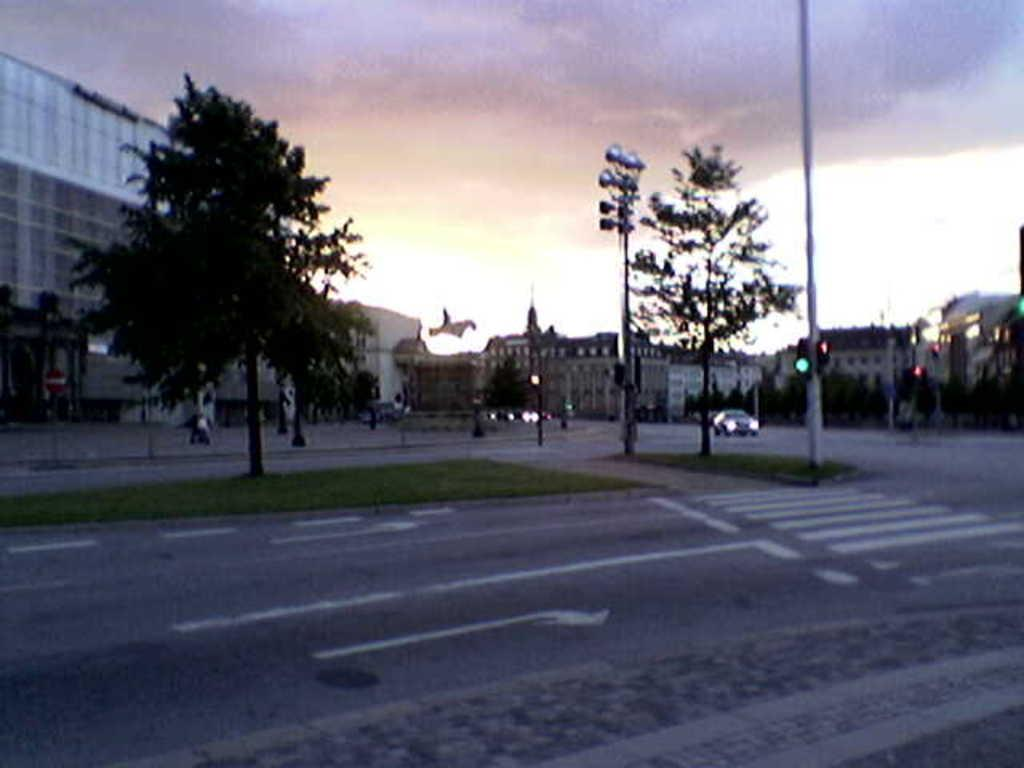What type of pathway can be seen in the image? There is a road in the image. What is moving along the road in the image? Vehicles are present in the image. What can be seen in the foreground of the image? The ground with a garden is visible in the image. What structures are present in the image? There are poles and a building with windows in the image. What is visible in the sky in the image? The sky is visible in the image, and clouds are present. Where is the cheese being stored in the image? There is no cheese present in the image. How many women are visible in the image? There are no women visible in the image. 